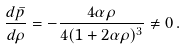Convert formula to latex. <formula><loc_0><loc_0><loc_500><loc_500>\frac { d \bar { p } } { d \rho } = - \frac { 4 \alpha \rho } { 4 \/ ( 1 + 2 \alpha \rho ) ^ { 3 } } \not = 0 \, .</formula> 